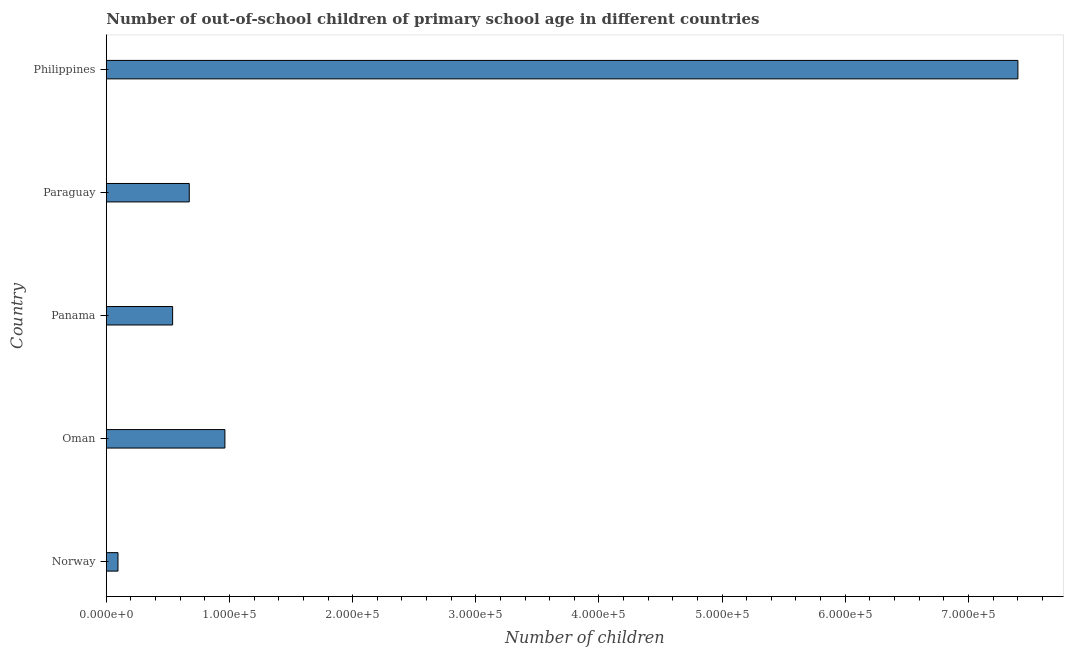Does the graph contain any zero values?
Offer a very short reply. No. Does the graph contain grids?
Your answer should be compact. No. What is the title of the graph?
Keep it short and to the point. Number of out-of-school children of primary school age in different countries. What is the label or title of the X-axis?
Give a very brief answer. Number of children. What is the number of out-of-school children in Norway?
Your answer should be very brief. 9461. Across all countries, what is the maximum number of out-of-school children?
Your answer should be compact. 7.40e+05. Across all countries, what is the minimum number of out-of-school children?
Offer a very short reply. 9461. In which country was the number of out-of-school children minimum?
Your answer should be compact. Norway. What is the sum of the number of out-of-school children?
Your response must be concise. 9.67e+05. What is the difference between the number of out-of-school children in Panama and Philippines?
Provide a succinct answer. -6.86e+05. What is the average number of out-of-school children per country?
Provide a short and direct response. 1.93e+05. What is the median number of out-of-school children?
Offer a very short reply. 6.73e+04. What is the ratio of the number of out-of-school children in Panama to that in Philippines?
Provide a short and direct response. 0.07. Is the number of out-of-school children in Norway less than that in Paraguay?
Ensure brevity in your answer.  Yes. Is the difference between the number of out-of-school children in Norway and Philippines greater than the difference between any two countries?
Offer a very short reply. Yes. What is the difference between the highest and the second highest number of out-of-school children?
Your answer should be compact. 6.44e+05. What is the difference between the highest and the lowest number of out-of-school children?
Ensure brevity in your answer.  7.31e+05. In how many countries, is the number of out-of-school children greater than the average number of out-of-school children taken over all countries?
Your answer should be very brief. 1. How many bars are there?
Make the answer very short. 5. How many countries are there in the graph?
Keep it short and to the point. 5. Are the values on the major ticks of X-axis written in scientific E-notation?
Your answer should be compact. Yes. What is the Number of children of Norway?
Ensure brevity in your answer.  9461. What is the Number of children in Oman?
Your response must be concise. 9.63e+04. What is the Number of children in Panama?
Your answer should be very brief. 5.38e+04. What is the Number of children in Paraguay?
Your answer should be compact. 6.73e+04. What is the Number of children of Philippines?
Ensure brevity in your answer.  7.40e+05. What is the difference between the Number of children in Norway and Oman?
Your response must be concise. -8.68e+04. What is the difference between the Number of children in Norway and Panama?
Offer a terse response. -4.44e+04. What is the difference between the Number of children in Norway and Paraguay?
Your answer should be very brief. -5.79e+04. What is the difference between the Number of children in Norway and Philippines?
Make the answer very short. -7.31e+05. What is the difference between the Number of children in Oman and Panama?
Make the answer very short. 4.24e+04. What is the difference between the Number of children in Oman and Paraguay?
Provide a short and direct response. 2.89e+04. What is the difference between the Number of children in Oman and Philippines?
Keep it short and to the point. -6.44e+05. What is the difference between the Number of children in Panama and Paraguay?
Provide a short and direct response. -1.35e+04. What is the difference between the Number of children in Panama and Philippines?
Keep it short and to the point. -6.86e+05. What is the difference between the Number of children in Paraguay and Philippines?
Ensure brevity in your answer.  -6.73e+05. What is the ratio of the Number of children in Norway to that in Oman?
Keep it short and to the point. 0.1. What is the ratio of the Number of children in Norway to that in Panama?
Your answer should be very brief. 0.18. What is the ratio of the Number of children in Norway to that in Paraguay?
Your response must be concise. 0.14. What is the ratio of the Number of children in Norway to that in Philippines?
Your answer should be compact. 0.01. What is the ratio of the Number of children in Oman to that in Panama?
Your answer should be compact. 1.79. What is the ratio of the Number of children in Oman to that in Paraguay?
Provide a succinct answer. 1.43. What is the ratio of the Number of children in Oman to that in Philippines?
Your answer should be compact. 0.13. What is the ratio of the Number of children in Panama to that in Paraguay?
Keep it short and to the point. 0.8. What is the ratio of the Number of children in Panama to that in Philippines?
Your answer should be compact. 0.07. What is the ratio of the Number of children in Paraguay to that in Philippines?
Provide a succinct answer. 0.09. 